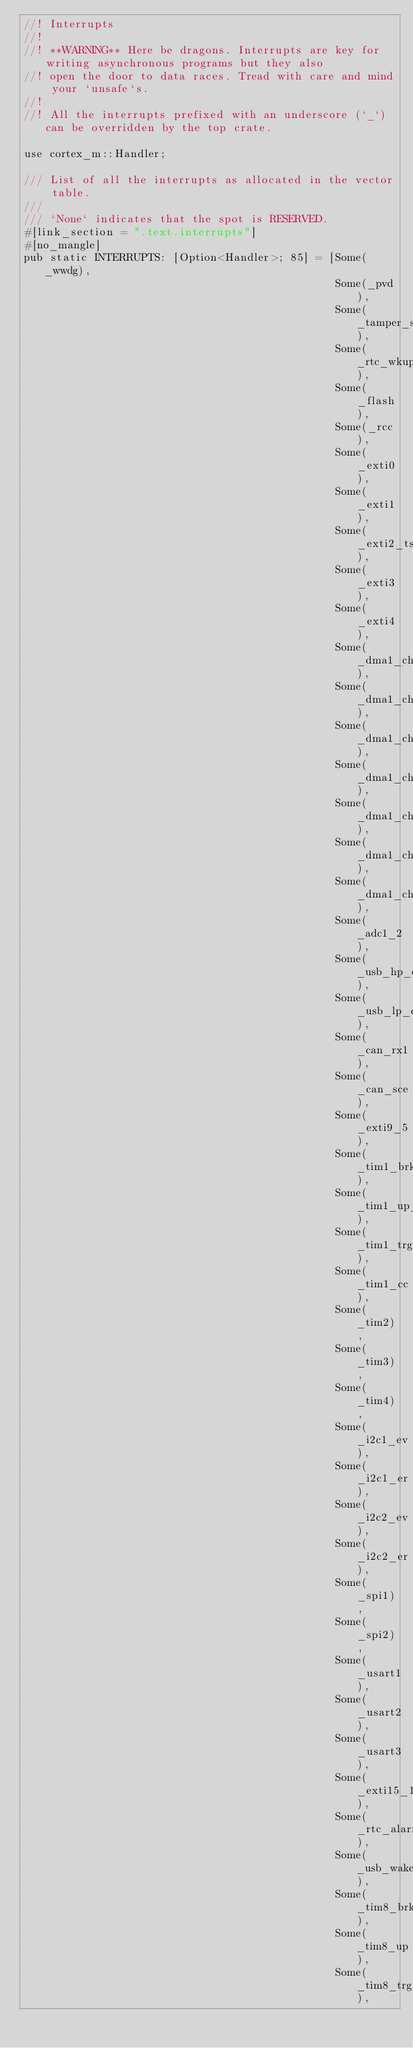<code> <loc_0><loc_0><loc_500><loc_500><_Rust_>//! Interrupts
//!
//! **WARNING** Here be dragons. Interrupts are key for writing asynchronous programs but they also
//! open the door to data races. Tread with care and mind your `unsafe`s.
//!
//! All the interrupts prefixed with an underscore (`_`) can be overridden by the top crate.

use cortex_m::Handler;

/// List of all the interrupts as allocated in the vector table.
///
/// `None` indicates that the spot is RESERVED.
#[link_section = ".text.interrupts"]
#[no_mangle]
pub static INTERRUPTS: [Option<Handler>; 85] = [Some(_wwdg),
                                                Some(_pvd),
                                                Some(_tamper_stamp),
                                                Some(_rtc_wkup),
                                                Some(_flash),
                                                Some(_rcc),
                                                Some(_exti0),
                                                Some(_exti1),
                                                Some(_exti2_ts),
                                                Some(_exti3),
                                                Some(_exti4),
                                                Some(_dma1_channel1),
                                                Some(_dma1_channel2),
                                                Some(_dma1_channel3),
                                                Some(_dma1_channel4),
                                                Some(_dma1_channel5),
                                                Some(_dma1_channel6),
                                                Some(_dma1_channel7),
                                                Some(_adc1_2),
                                                Some(_usb_hp_can_tx),
                                                Some(_usb_lp_can_rx0),
                                                Some(_can_rx1),
                                                Some(_can_sce),
                                                Some(_exti9_5),
                                                Some(_tim1_brk_tim15),
                                                Some(_tim1_up_tim16),
                                                Some(_tim1_trg_com_tim17),
                                                Some(_tim1_cc),
                                                Some(_tim2),
                                                Some(_tim3),
                                                Some(_tim4),
                                                Some(_i2c1_ev),
                                                Some(_i2c1_er),
                                                Some(_i2c2_ev),
                                                Some(_i2c2_er),
                                                Some(_spi1),
                                                Some(_spi2),
                                                Some(_usart1),
                                                Some(_usart2),
                                                Some(_usart3),
                                                Some(_exti15_10),
                                                Some(_rtc_alarm),
                                                Some(_usb_wake_up),
                                                Some(_tim8_brk),
                                                Some(_tim8_up),
                                                Some(_tim8_trg_com),</code> 